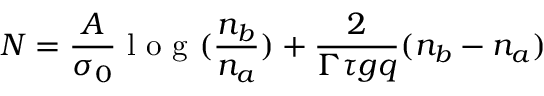<formula> <loc_0><loc_0><loc_500><loc_500>N = \frac { A } { \sigma _ { 0 } } \log ( \frac { n _ { b } } { n _ { a } } ) + \frac { 2 } { \Gamma \tau g q } ( n _ { b } - n _ { a } )</formula> 